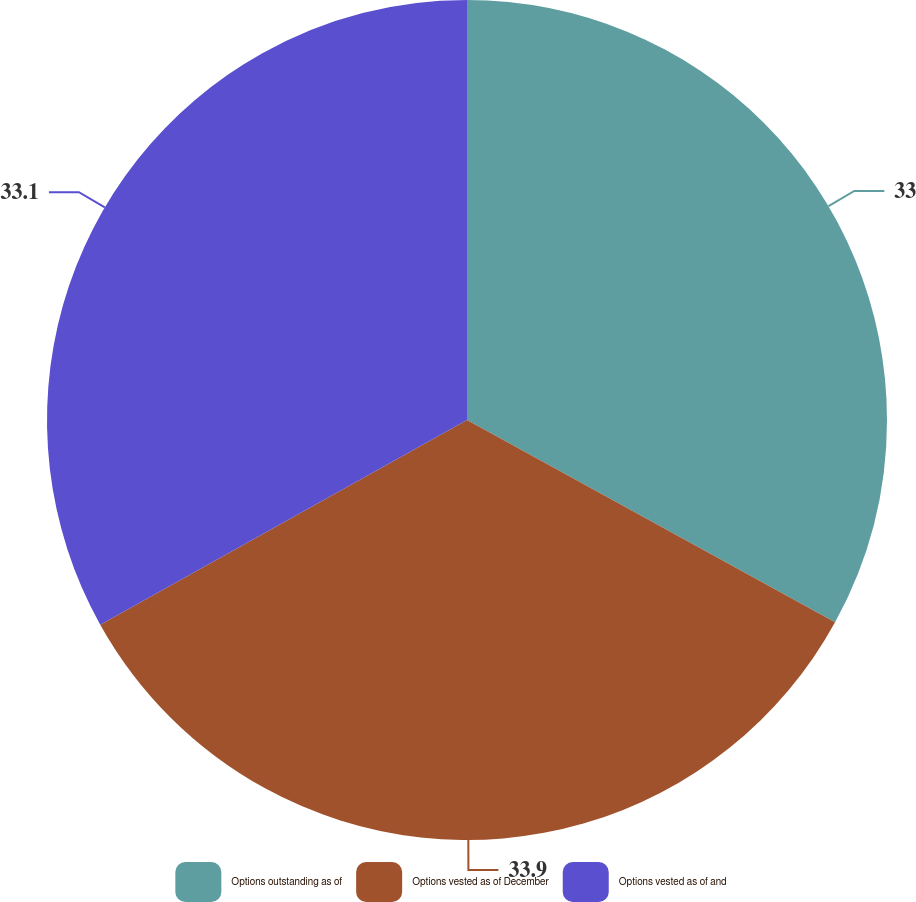Convert chart to OTSL. <chart><loc_0><loc_0><loc_500><loc_500><pie_chart><fcel>Options outstanding as of<fcel>Options vested as of December<fcel>Options vested as of and<nl><fcel>33.0%<fcel>33.9%<fcel>33.1%<nl></chart> 